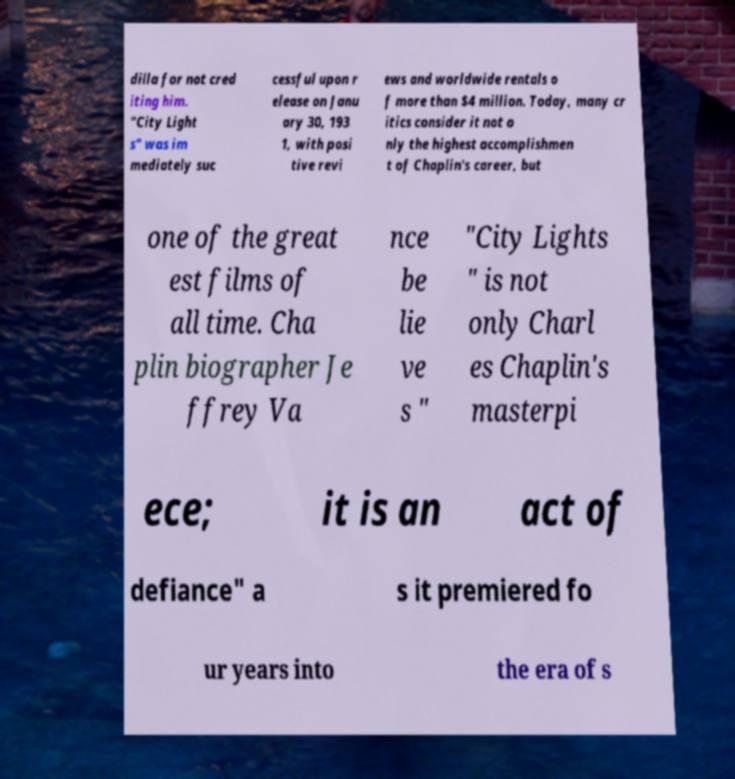For documentation purposes, I need the text within this image transcribed. Could you provide that? dilla for not cred iting him. "City Light s" was im mediately suc cessful upon r elease on Janu ary 30, 193 1, with posi tive revi ews and worldwide rentals o f more than $4 million. Today, many cr itics consider it not o nly the highest accomplishmen t of Chaplin's career, but one of the great est films of all time. Cha plin biographer Je ffrey Va nce be lie ve s " "City Lights " is not only Charl es Chaplin's masterpi ece; it is an act of defiance" a s it premiered fo ur years into the era of s 